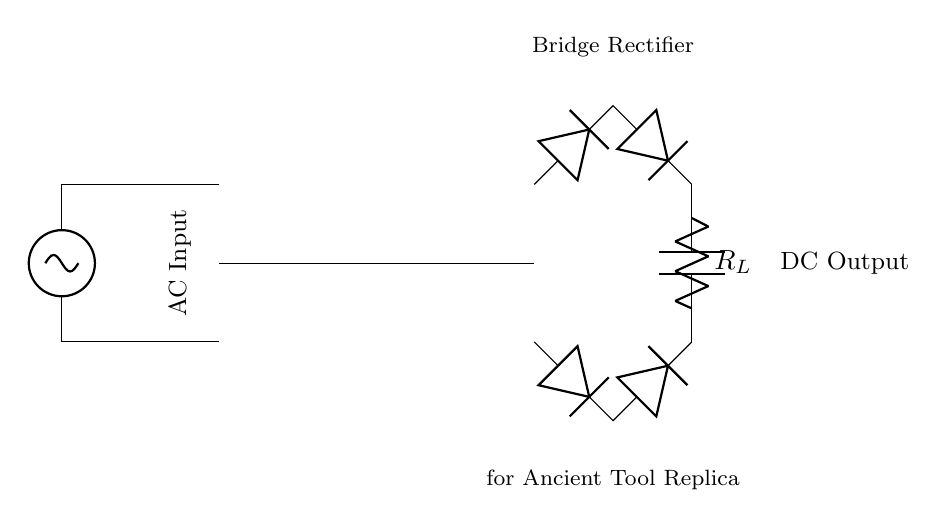What type of input does the circuit accept? The circuit diagram indicates that the input is an alternating current (AC) since it is labeled as AC Input at the beginning of the diagram. This is typical for rectifier circuits, which convert AC to DC.
Answer: AC What components make up the rectifier bridge? The rectifier bridge consists of four diodes connected in a specific arrangement. Each diode is indicated in the diagram, showing two connections at the top and two at the bottom, which allows for the rectification process.
Answer: Four diodes What type of load is connected to the rectifier? The load in this circuit is represented as a resistor labeled R_L, which signifies that it is a resistive load typically used in rectifier applications.
Answer: Resistor Why is a capacitor included in this circuit? The capacitor is included to smooth out the output voltage after rectification. It charges and discharges to reduce voltage ripple, providing a more stable direct current (DC) output suitable for powering devices.
Answer: To smooth the output What is the purpose of the transformer in this circuit? The transformer is used to step down or step up the voltage from the AC supply to a suitable level for the rectifier and load. Its primary function is to convert the input voltage to the desired output voltage.
Answer: Voltage conversion How many diodes are used in the rectifier? The circuit uses four diodes, as shown in the bridge rectifier configuration, to allow current to flow in both directions, converting the AC input to a pulsating DC output.
Answer: Four What kind of output does this circuit produce? The output produced by this circuit is direct current (DC), as indicated by the DC Output label, which is the result of the rectification of the AC input through the diodes.
Answer: DC 